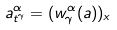<formula> <loc_0><loc_0><loc_500><loc_500>a _ { t ^ { \gamma } } ^ { \alpha } = ( w _ { \gamma } ^ { \alpha } ( a ) ) _ { x }</formula> 